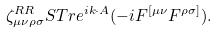<formula> <loc_0><loc_0><loc_500><loc_500>\zeta _ { \mu \nu \rho \sigma } ^ { R R } S T r e ^ { i k \cdot A } ( - i F ^ { [ \mu \nu } F ^ { \rho \sigma ] } ) .</formula> 